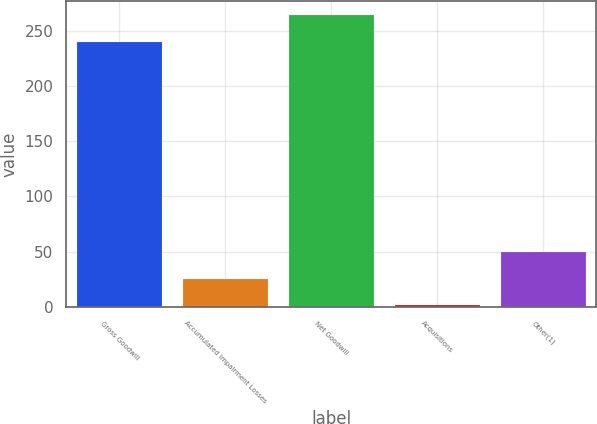<chart> <loc_0><loc_0><loc_500><loc_500><bar_chart><fcel>Gross Goodwill<fcel>Accumulated Impairment Losses<fcel>Net Goodwill<fcel>Acquisitions<fcel>Other(1)<nl><fcel>240<fcel>25.4<fcel>263.84<fcel>1.56<fcel>49.24<nl></chart> 